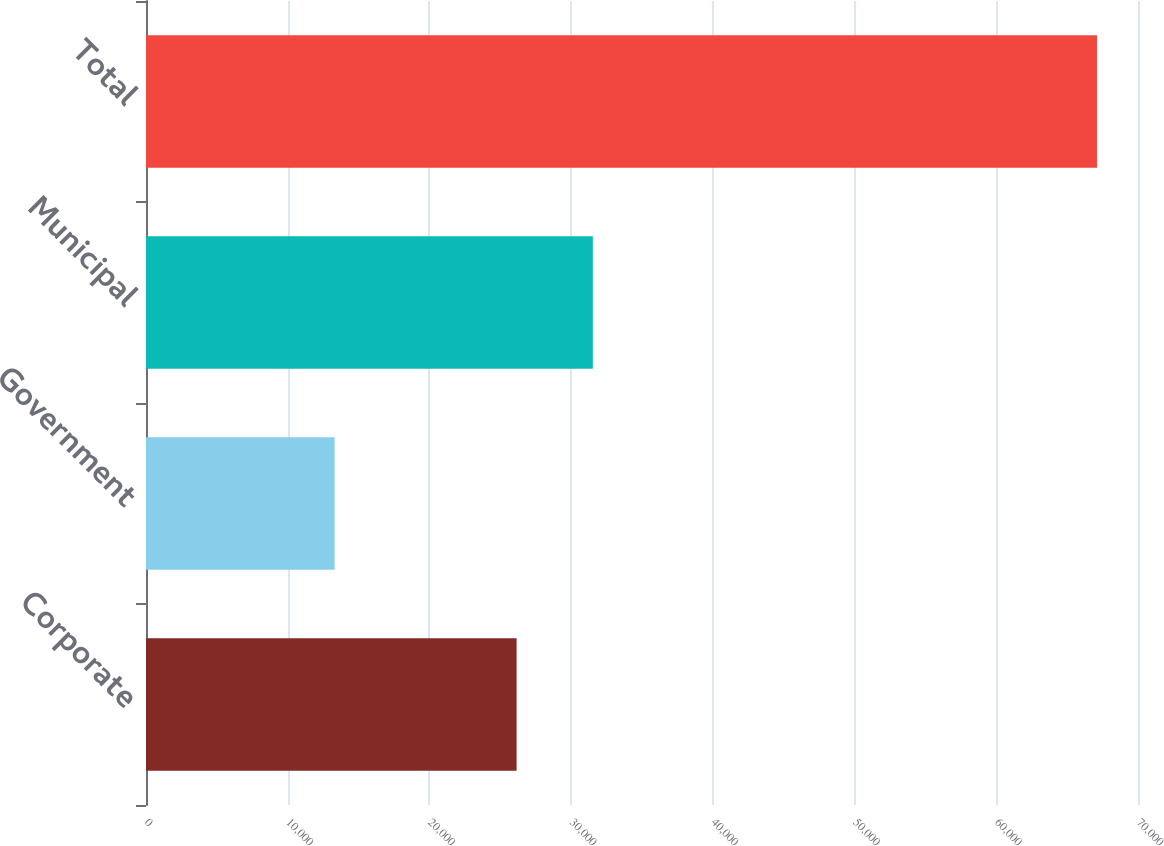<chart> <loc_0><loc_0><loc_500><loc_500><bar_chart><fcel>Corporate<fcel>Government<fcel>Municipal<fcel>Total<nl><fcel>26151<fcel>13309<fcel>31530.7<fcel>67106<nl></chart> 